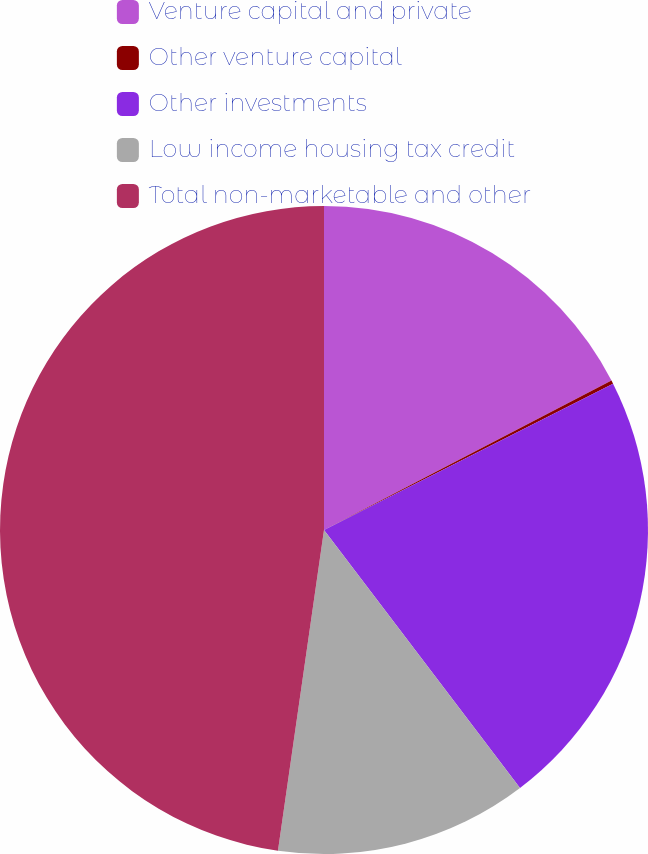Convert chart. <chart><loc_0><loc_0><loc_500><loc_500><pie_chart><fcel>Venture capital and private<fcel>Other venture capital<fcel>Other investments<fcel>Low income housing tax credit<fcel>Total non-marketable and other<nl><fcel>17.37%<fcel>0.17%<fcel>22.12%<fcel>12.61%<fcel>47.73%<nl></chart> 